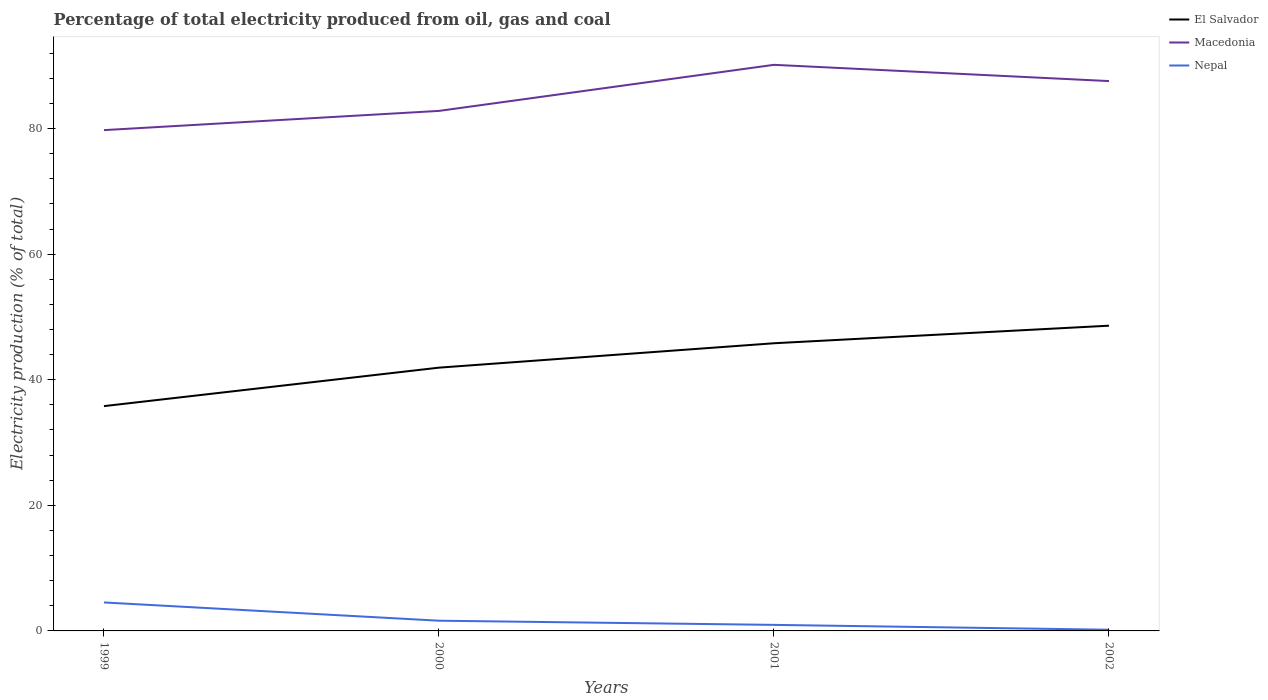How many different coloured lines are there?
Give a very brief answer. 3. Is the number of lines equal to the number of legend labels?
Offer a terse response. Yes. Across all years, what is the maximum electricity production in in Macedonia?
Provide a succinct answer. 79.76. What is the total electricity production in in El Salvador in the graph?
Your answer should be very brief. -3.88. What is the difference between the highest and the second highest electricity production in in Nepal?
Keep it short and to the point. 4.34. Is the electricity production in in El Salvador strictly greater than the electricity production in in Macedonia over the years?
Offer a terse response. Yes. How many years are there in the graph?
Your response must be concise. 4. Are the values on the major ticks of Y-axis written in scientific E-notation?
Keep it short and to the point. No. Does the graph contain grids?
Make the answer very short. No. What is the title of the graph?
Keep it short and to the point. Percentage of total electricity produced from oil, gas and coal. Does "Tuvalu" appear as one of the legend labels in the graph?
Give a very brief answer. No. What is the label or title of the X-axis?
Your answer should be compact. Years. What is the label or title of the Y-axis?
Offer a terse response. Electricity production (% of total). What is the Electricity production (% of total) in El Salvador in 1999?
Give a very brief answer. 35.8. What is the Electricity production (% of total) in Macedonia in 1999?
Your response must be concise. 79.76. What is the Electricity production (% of total) of Nepal in 1999?
Offer a terse response. 4.53. What is the Electricity production (% of total) in El Salvador in 2000?
Your response must be concise. 41.93. What is the Electricity production (% of total) of Macedonia in 2000?
Provide a short and direct response. 82.82. What is the Electricity production (% of total) of Nepal in 2000?
Your answer should be very brief. 1.63. What is the Electricity production (% of total) in El Salvador in 2001?
Give a very brief answer. 45.82. What is the Electricity production (% of total) of Macedonia in 2001?
Provide a short and direct response. 90.16. What is the Electricity production (% of total) of Nepal in 2001?
Provide a succinct answer. 0.96. What is the Electricity production (% of total) of El Salvador in 2002?
Offer a very short reply. 48.61. What is the Electricity production (% of total) of Macedonia in 2002?
Ensure brevity in your answer.  87.57. What is the Electricity production (% of total) in Nepal in 2002?
Give a very brief answer. 0.19. Across all years, what is the maximum Electricity production (% of total) of El Salvador?
Your answer should be very brief. 48.61. Across all years, what is the maximum Electricity production (% of total) in Macedonia?
Offer a very short reply. 90.16. Across all years, what is the maximum Electricity production (% of total) of Nepal?
Offer a very short reply. 4.53. Across all years, what is the minimum Electricity production (% of total) of El Salvador?
Give a very brief answer. 35.8. Across all years, what is the minimum Electricity production (% of total) in Macedonia?
Your response must be concise. 79.76. Across all years, what is the minimum Electricity production (% of total) of Nepal?
Provide a succinct answer. 0.19. What is the total Electricity production (% of total) of El Salvador in the graph?
Your answer should be compact. 172.16. What is the total Electricity production (% of total) of Macedonia in the graph?
Offer a terse response. 340.32. What is the total Electricity production (% of total) in Nepal in the graph?
Offer a terse response. 7.31. What is the difference between the Electricity production (% of total) of El Salvador in 1999 and that in 2000?
Your answer should be very brief. -6.13. What is the difference between the Electricity production (% of total) of Macedonia in 1999 and that in 2000?
Keep it short and to the point. -3.06. What is the difference between the Electricity production (% of total) in Nepal in 1999 and that in 2000?
Provide a succinct answer. 2.91. What is the difference between the Electricity production (% of total) of El Salvador in 1999 and that in 2001?
Provide a succinct answer. -10.01. What is the difference between the Electricity production (% of total) of Macedonia in 1999 and that in 2001?
Offer a terse response. -10.4. What is the difference between the Electricity production (% of total) in Nepal in 1999 and that in 2001?
Offer a very short reply. 3.57. What is the difference between the Electricity production (% of total) of El Salvador in 1999 and that in 2002?
Make the answer very short. -12.81. What is the difference between the Electricity production (% of total) of Macedonia in 1999 and that in 2002?
Your response must be concise. -7.81. What is the difference between the Electricity production (% of total) in Nepal in 1999 and that in 2002?
Make the answer very short. 4.34. What is the difference between the Electricity production (% of total) of El Salvador in 2000 and that in 2001?
Offer a very short reply. -3.88. What is the difference between the Electricity production (% of total) in Macedonia in 2000 and that in 2001?
Your response must be concise. -7.34. What is the difference between the Electricity production (% of total) of Nepal in 2000 and that in 2001?
Provide a succinct answer. 0.66. What is the difference between the Electricity production (% of total) in El Salvador in 2000 and that in 2002?
Provide a short and direct response. -6.68. What is the difference between the Electricity production (% of total) in Macedonia in 2000 and that in 2002?
Provide a succinct answer. -4.75. What is the difference between the Electricity production (% of total) of Nepal in 2000 and that in 2002?
Your response must be concise. 1.44. What is the difference between the Electricity production (% of total) in El Salvador in 2001 and that in 2002?
Ensure brevity in your answer.  -2.8. What is the difference between the Electricity production (% of total) of Macedonia in 2001 and that in 2002?
Your answer should be very brief. 2.59. What is the difference between the Electricity production (% of total) in Nepal in 2001 and that in 2002?
Your answer should be very brief. 0.78. What is the difference between the Electricity production (% of total) of El Salvador in 1999 and the Electricity production (% of total) of Macedonia in 2000?
Provide a short and direct response. -47.02. What is the difference between the Electricity production (% of total) in El Salvador in 1999 and the Electricity production (% of total) in Nepal in 2000?
Offer a terse response. 34.18. What is the difference between the Electricity production (% of total) in Macedonia in 1999 and the Electricity production (% of total) in Nepal in 2000?
Your response must be concise. 78.13. What is the difference between the Electricity production (% of total) of El Salvador in 1999 and the Electricity production (% of total) of Macedonia in 2001?
Ensure brevity in your answer.  -54.36. What is the difference between the Electricity production (% of total) in El Salvador in 1999 and the Electricity production (% of total) in Nepal in 2001?
Your answer should be compact. 34.84. What is the difference between the Electricity production (% of total) of Macedonia in 1999 and the Electricity production (% of total) of Nepal in 2001?
Your answer should be very brief. 78.8. What is the difference between the Electricity production (% of total) in El Salvador in 1999 and the Electricity production (% of total) in Macedonia in 2002?
Your answer should be compact. -51.77. What is the difference between the Electricity production (% of total) in El Salvador in 1999 and the Electricity production (% of total) in Nepal in 2002?
Your response must be concise. 35.62. What is the difference between the Electricity production (% of total) of Macedonia in 1999 and the Electricity production (% of total) of Nepal in 2002?
Ensure brevity in your answer.  79.57. What is the difference between the Electricity production (% of total) of El Salvador in 2000 and the Electricity production (% of total) of Macedonia in 2001?
Keep it short and to the point. -48.23. What is the difference between the Electricity production (% of total) of El Salvador in 2000 and the Electricity production (% of total) of Nepal in 2001?
Give a very brief answer. 40.97. What is the difference between the Electricity production (% of total) of Macedonia in 2000 and the Electricity production (% of total) of Nepal in 2001?
Give a very brief answer. 81.86. What is the difference between the Electricity production (% of total) in El Salvador in 2000 and the Electricity production (% of total) in Macedonia in 2002?
Your answer should be very brief. -45.64. What is the difference between the Electricity production (% of total) of El Salvador in 2000 and the Electricity production (% of total) of Nepal in 2002?
Your answer should be very brief. 41.74. What is the difference between the Electricity production (% of total) in Macedonia in 2000 and the Electricity production (% of total) in Nepal in 2002?
Your response must be concise. 82.63. What is the difference between the Electricity production (% of total) of El Salvador in 2001 and the Electricity production (% of total) of Macedonia in 2002?
Make the answer very short. -41.76. What is the difference between the Electricity production (% of total) of El Salvador in 2001 and the Electricity production (% of total) of Nepal in 2002?
Provide a short and direct response. 45.63. What is the difference between the Electricity production (% of total) in Macedonia in 2001 and the Electricity production (% of total) in Nepal in 2002?
Provide a succinct answer. 89.97. What is the average Electricity production (% of total) of El Salvador per year?
Your answer should be compact. 43.04. What is the average Electricity production (% of total) in Macedonia per year?
Offer a very short reply. 85.08. What is the average Electricity production (% of total) in Nepal per year?
Your answer should be compact. 1.83. In the year 1999, what is the difference between the Electricity production (% of total) in El Salvador and Electricity production (% of total) in Macedonia?
Your answer should be very brief. -43.96. In the year 1999, what is the difference between the Electricity production (% of total) in El Salvador and Electricity production (% of total) in Nepal?
Provide a short and direct response. 31.27. In the year 1999, what is the difference between the Electricity production (% of total) in Macedonia and Electricity production (% of total) in Nepal?
Provide a succinct answer. 75.23. In the year 2000, what is the difference between the Electricity production (% of total) of El Salvador and Electricity production (% of total) of Macedonia?
Provide a short and direct response. -40.89. In the year 2000, what is the difference between the Electricity production (% of total) of El Salvador and Electricity production (% of total) of Nepal?
Your answer should be compact. 40.3. In the year 2000, what is the difference between the Electricity production (% of total) of Macedonia and Electricity production (% of total) of Nepal?
Provide a succinct answer. 81.19. In the year 2001, what is the difference between the Electricity production (% of total) in El Salvador and Electricity production (% of total) in Macedonia?
Ensure brevity in your answer.  -44.34. In the year 2001, what is the difference between the Electricity production (% of total) of El Salvador and Electricity production (% of total) of Nepal?
Your answer should be very brief. 44.85. In the year 2001, what is the difference between the Electricity production (% of total) of Macedonia and Electricity production (% of total) of Nepal?
Offer a very short reply. 89.2. In the year 2002, what is the difference between the Electricity production (% of total) of El Salvador and Electricity production (% of total) of Macedonia?
Your response must be concise. -38.96. In the year 2002, what is the difference between the Electricity production (% of total) in El Salvador and Electricity production (% of total) in Nepal?
Offer a very short reply. 48.43. In the year 2002, what is the difference between the Electricity production (% of total) of Macedonia and Electricity production (% of total) of Nepal?
Provide a short and direct response. 87.38. What is the ratio of the Electricity production (% of total) in El Salvador in 1999 to that in 2000?
Keep it short and to the point. 0.85. What is the ratio of the Electricity production (% of total) in Macedonia in 1999 to that in 2000?
Your response must be concise. 0.96. What is the ratio of the Electricity production (% of total) of Nepal in 1999 to that in 2000?
Give a very brief answer. 2.79. What is the ratio of the Electricity production (% of total) in El Salvador in 1999 to that in 2001?
Your answer should be compact. 0.78. What is the ratio of the Electricity production (% of total) of Macedonia in 1999 to that in 2001?
Your answer should be compact. 0.88. What is the ratio of the Electricity production (% of total) of Nepal in 1999 to that in 2001?
Your answer should be compact. 4.7. What is the ratio of the Electricity production (% of total) in El Salvador in 1999 to that in 2002?
Your answer should be compact. 0.74. What is the ratio of the Electricity production (% of total) in Macedonia in 1999 to that in 2002?
Make the answer very short. 0.91. What is the ratio of the Electricity production (% of total) in Nepal in 1999 to that in 2002?
Offer a terse response. 24.06. What is the ratio of the Electricity production (% of total) of El Salvador in 2000 to that in 2001?
Your response must be concise. 0.92. What is the ratio of the Electricity production (% of total) in Macedonia in 2000 to that in 2001?
Make the answer very short. 0.92. What is the ratio of the Electricity production (% of total) in Nepal in 2000 to that in 2001?
Give a very brief answer. 1.69. What is the ratio of the Electricity production (% of total) in El Salvador in 2000 to that in 2002?
Give a very brief answer. 0.86. What is the ratio of the Electricity production (% of total) of Macedonia in 2000 to that in 2002?
Give a very brief answer. 0.95. What is the ratio of the Electricity production (% of total) of Nepal in 2000 to that in 2002?
Provide a short and direct response. 8.64. What is the ratio of the Electricity production (% of total) in El Salvador in 2001 to that in 2002?
Keep it short and to the point. 0.94. What is the ratio of the Electricity production (% of total) of Macedonia in 2001 to that in 2002?
Provide a succinct answer. 1.03. What is the ratio of the Electricity production (% of total) of Nepal in 2001 to that in 2002?
Offer a terse response. 5.12. What is the difference between the highest and the second highest Electricity production (% of total) in El Salvador?
Offer a very short reply. 2.8. What is the difference between the highest and the second highest Electricity production (% of total) in Macedonia?
Your answer should be compact. 2.59. What is the difference between the highest and the second highest Electricity production (% of total) in Nepal?
Provide a succinct answer. 2.91. What is the difference between the highest and the lowest Electricity production (% of total) of El Salvador?
Your answer should be very brief. 12.81. What is the difference between the highest and the lowest Electricity production (% of total) in Macedonia?
Provide a succinct answer. 10.4. What is the difference between the highest and the lowest Electricity production (% of total) of Nepal?
Your response must be concise. 4.34. 